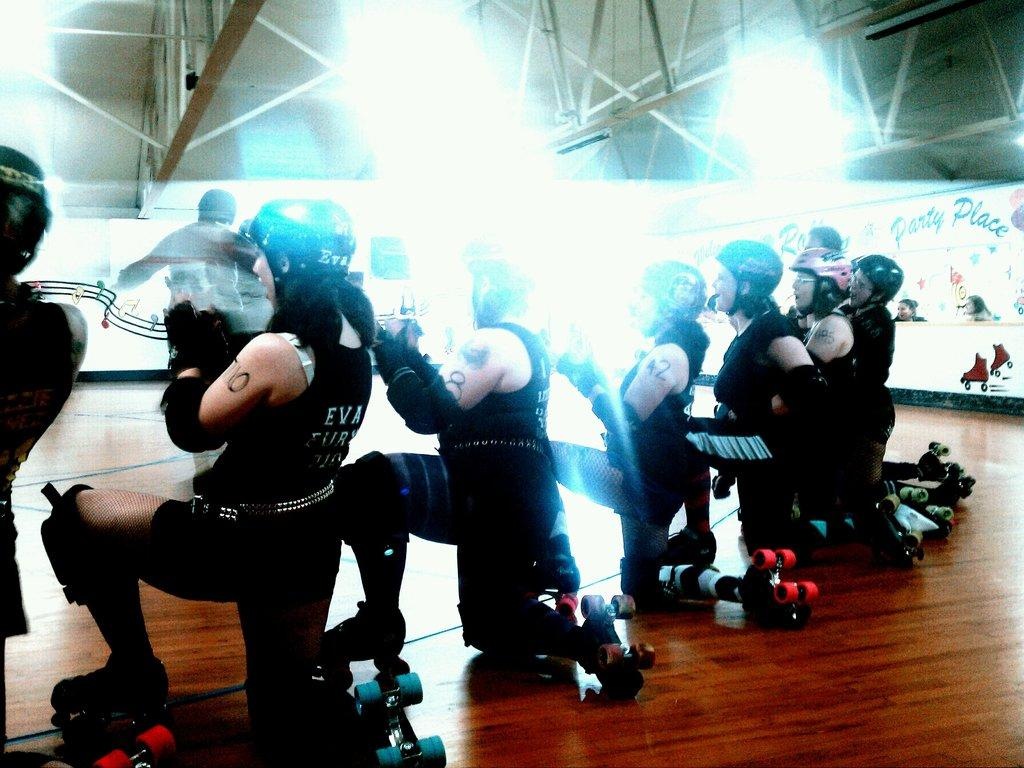What type of footwear are the people wearing in the image? The people in the image are wearing skating shoes. What can be seen on the wall in the image? There is a wall with images and text in the image. What material is used for the rods at the top of the image? The rods at the top of the image are made of metal. How does the aunt express her anger in the image? There is no aunt present in the image, nor is there any indication of anger. 